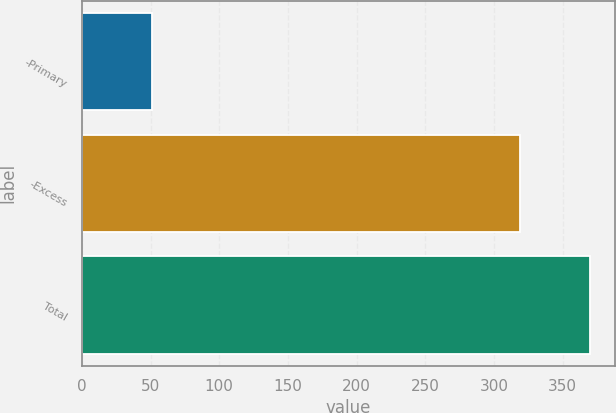<chart> <loc_0><loc_0><loc_500><loc_500><bar_chart><fcel>-Primary<fcel>-Excess<fcel>Total<nl><fcel>51<fcel>319<fcel>370<nl></chart> 